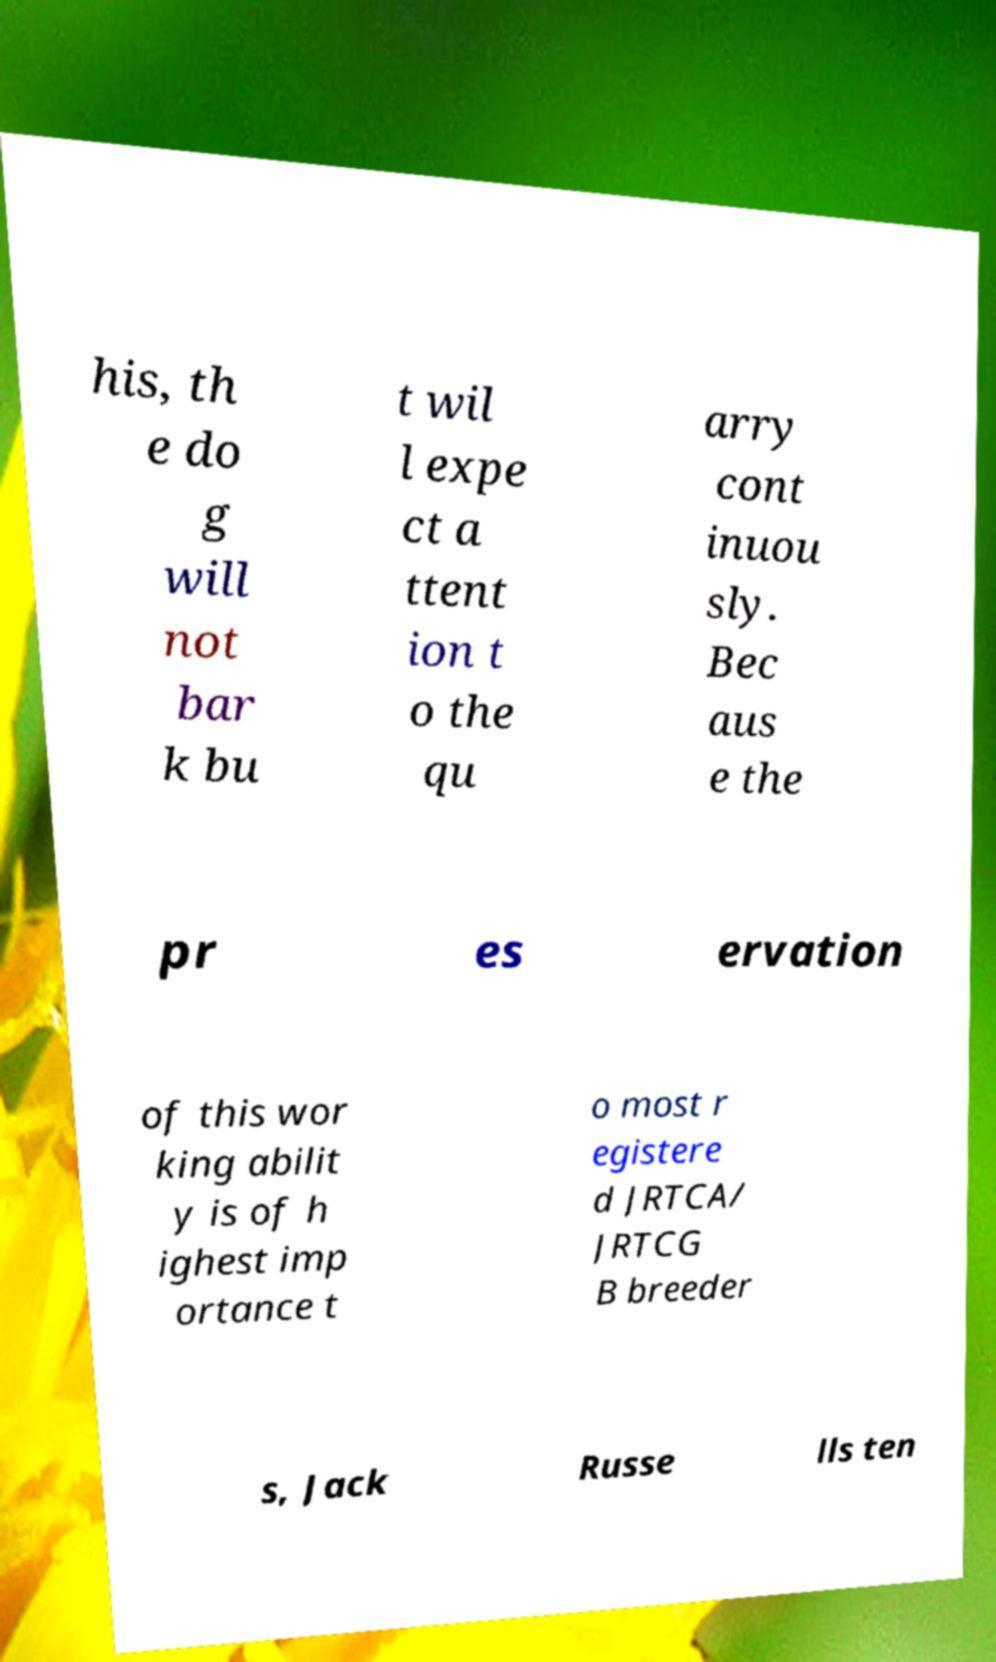Could you extract and type out the text from this image? his, th e do g will not bar k bu t wil l expe ct a ttent ion t o the qu arry cont inuou sly. Bec aus e the pr es ervation of this wor king abilit y is of h ighest imp ortance t o most r egistere d JRTCA/ JRTCG B breeder s, Jack Russe lls ten 